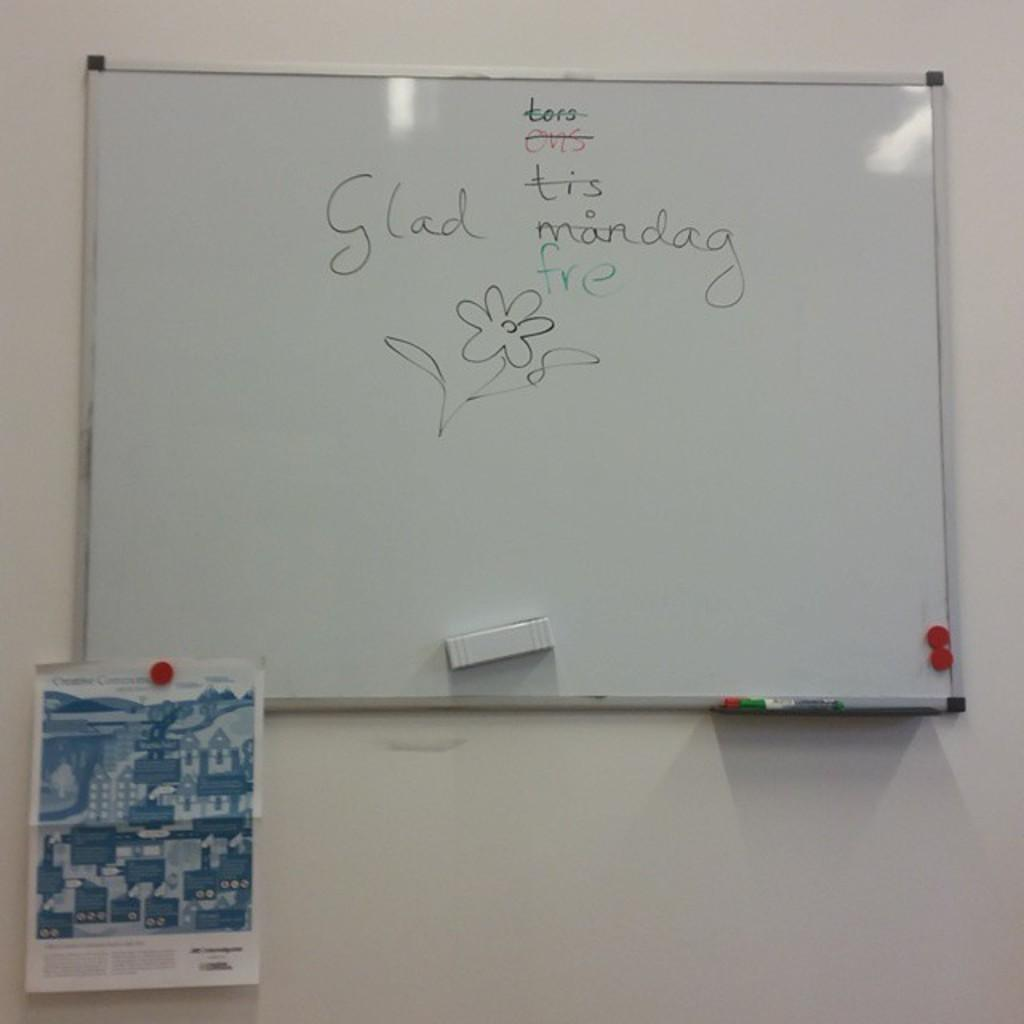<image>
Create a compact narrative representing the image presented. A white board on the wall with writing that says "Glad freday". 